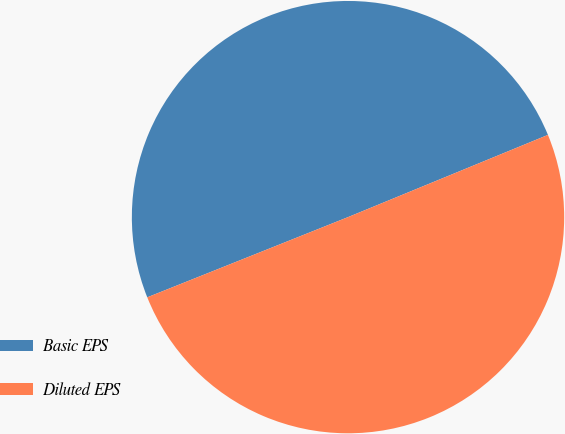Convert chart to OTSL. <chart><loc_0><loc_0><loc_500><loc_500><pie_chart><fcel>Basic EPS<fcel>Diluted EPS<nl><fcel>49.84%<fcel>50.16%<nl></chart> 